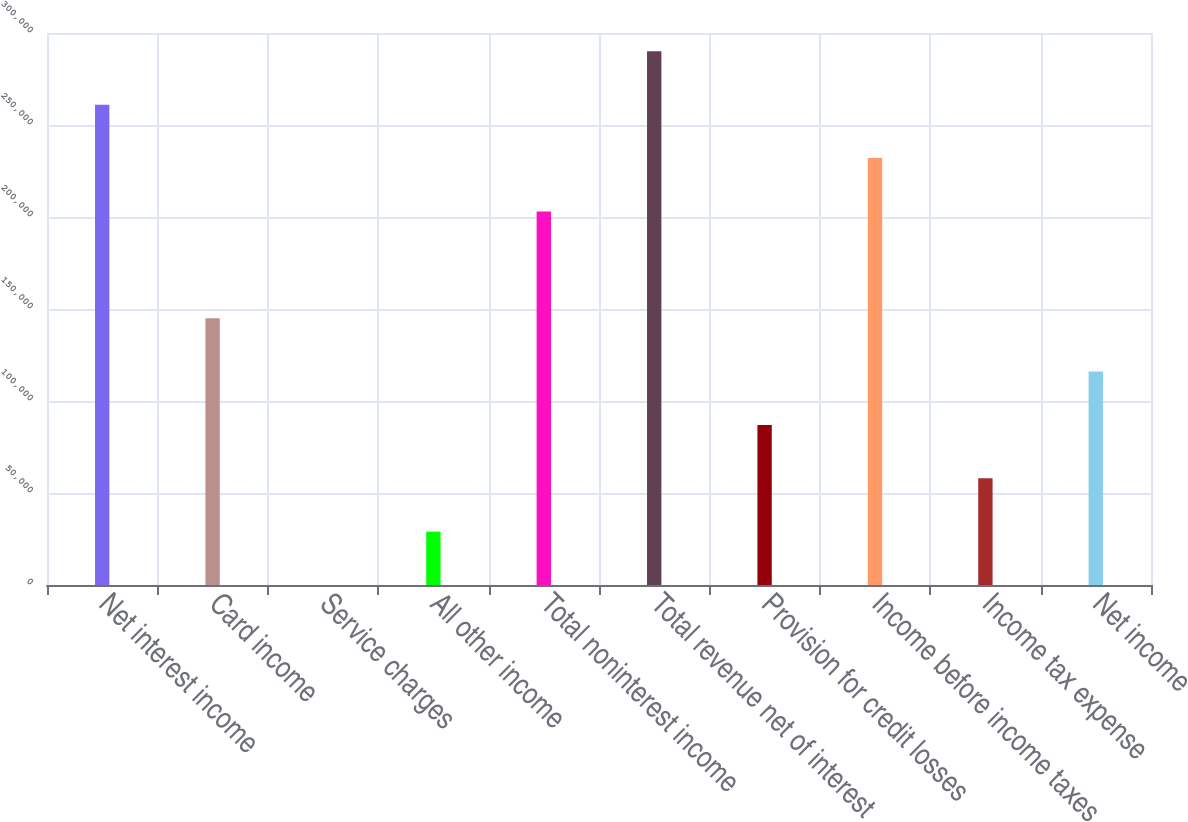<chart> <loc_0><loc_0><loc_500><loc_500><bar_chart><fcel>Net interest income<fcel>Card income<fcel>Service charges<fcel>All other income<fcel>Total noninterest income<fcel>Total revenue net of interest<fcel>Provision for credit losses<fcel>Income before income taxes<fcel>Income tax expense<fcel>Net income<nl><fcel>261061<fcel>145035<fcel>2<fcel>29008.6<fcel>203048<fcel>290068<fcel>87021.8<fcel>232055<fcel>58015.2<fcel>116028<nl></chart> 